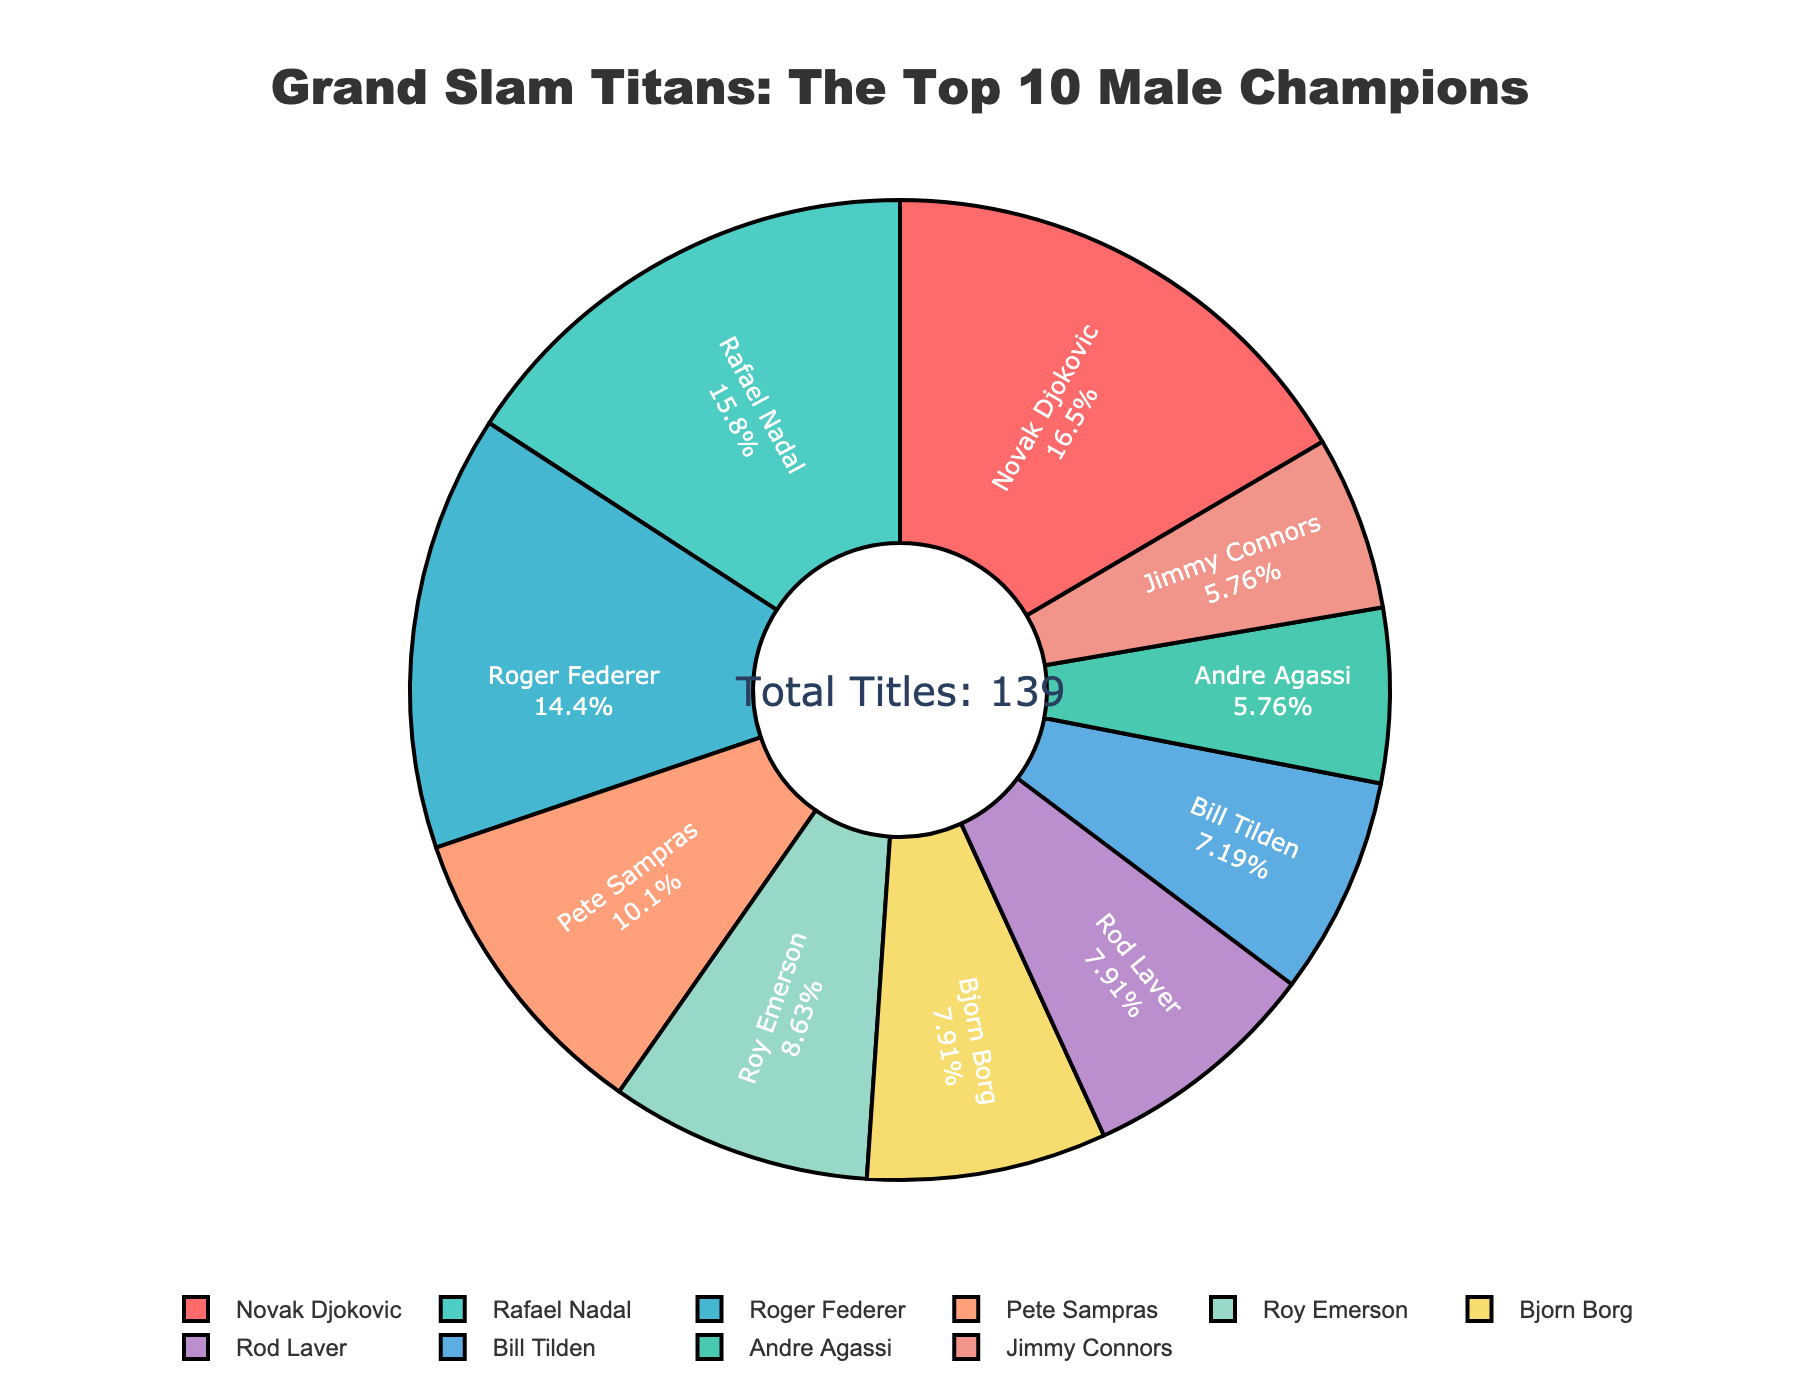Which player has the highest number of Grand Slam titles? To determine which player has the highest number of Grand Slam titles, look at the player with the largest segment in the pie chart. From the chart, it is clear that Novak Djokovic has the largest segment.
Answer: Novak Djokovic Who has more Grand Slam titles, Roger Federer or Pete Sampras? Compare the segments representing Roger Federer and Pete Sampras in the pie chart. Roger Federer has 20 titles, whereas Pete Sampras has 14.
Answer: Roger Federer How many more Grand Slam titles does Rafael Nadal have compared to Andre Agassi? Refer to the segments for Rafael Nadal and Andre Agassi. Nadal has 22 titles and Agassi has 8 titles. Subtract Agassi's titles from Nadal's titles: 22 - 8.
Answer: 14 Which two players have an equal number of Grand Slam titles? Identify the players whose segments in the pie chart are identical in size. Both Bjorn Borg and Rod Laver have 11 titles each, as indicated by their equal-sized segments.
Answer: Bjorn Borg and Rod Laver What is the combined total of Grand Slam titles for Novak Djokovic, Rafael Nadal, and Roger Federer? Add the number of titles for Djokovic (23), Nadal (22), and Federer (20). Calculate the sum: 23 + 22 + 20.
Answer: 65 What percentage of the total Grand Slam titles does Roy Emerson hold? The total number of Grand Slam titles can be added from all players listed: 23 + 22 + 20 + 14 + 12 + 11 + 11 + 10 + 8 + 8 = 139. Calculate the percentage for Roy Emerson: (12 / 139) * 100%.
Answer: Approximately 8.63% Which player has the smallest segment in the pie chart and how many titles does he have? Find the player with the smallest segment visually. Both Andre Agassi and Jimmy Connors have the smallest segments, each with 8 titles.
Answer: Andre Agassi and Jimmy Connors, 8 titles each How many players have won more than 20 Grand Slam titles? Count the segments representing players who have more than 20 titles. Only Novak Djokovic and Rafael Nadal have segments that represent more than 20 titles.
Answer: 2 If you combine the Grand Slam titles of Pete Sampras and Roy Emerson, would they surpass Roger Federer? Add the titles of Pete Sampras (14) and Roy Emerson (12): 14 + 12. Then compare their combined total with Roger Federer's titles (20).
Answer: No, 26 vs 20 What is the difference in percentage points between the players with the highest and lowest number of Grand Slam titles? Identify the highest (Novak Djokovic with 23 titles) and lowest (Andre Agassi and Jimmy Connors with 8 titles each). Calculate their percentages: (23 / 139) * 100% for Djokovic and (8 / 139) * 100% for Agassi/Connors. Then subtract the smallest from the largest percentage.
Answer: Approximately 10.79 percentage points 